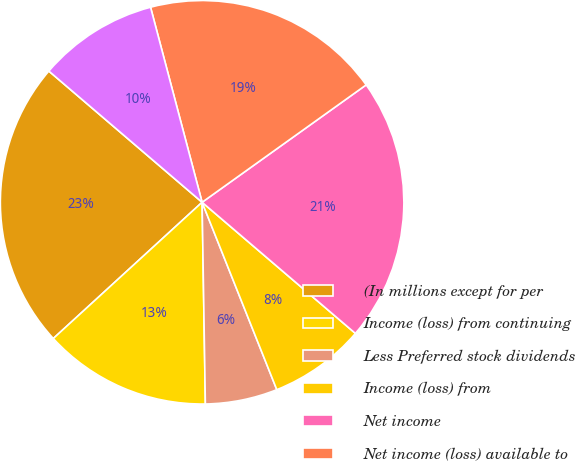Convert chart to OTSL. <chart><loc_0><loc_0><loc_500><loc_500><pie_chart><fcel>(In millions except for per<fcel>Income (loss) from continuing<fcel>Less Preferred stock dividends<fcel>Income (loss) from<fcel>Net income<fcel>Net income (loss) available to<fcel>Weighted average common shares<nl><fcel>23.07%<fcel>13.46%<fcel>5.78%<fcel>7.7%<fcel>21.15%<fcel>19.23%<fcel>9.62%<nl></chart> 